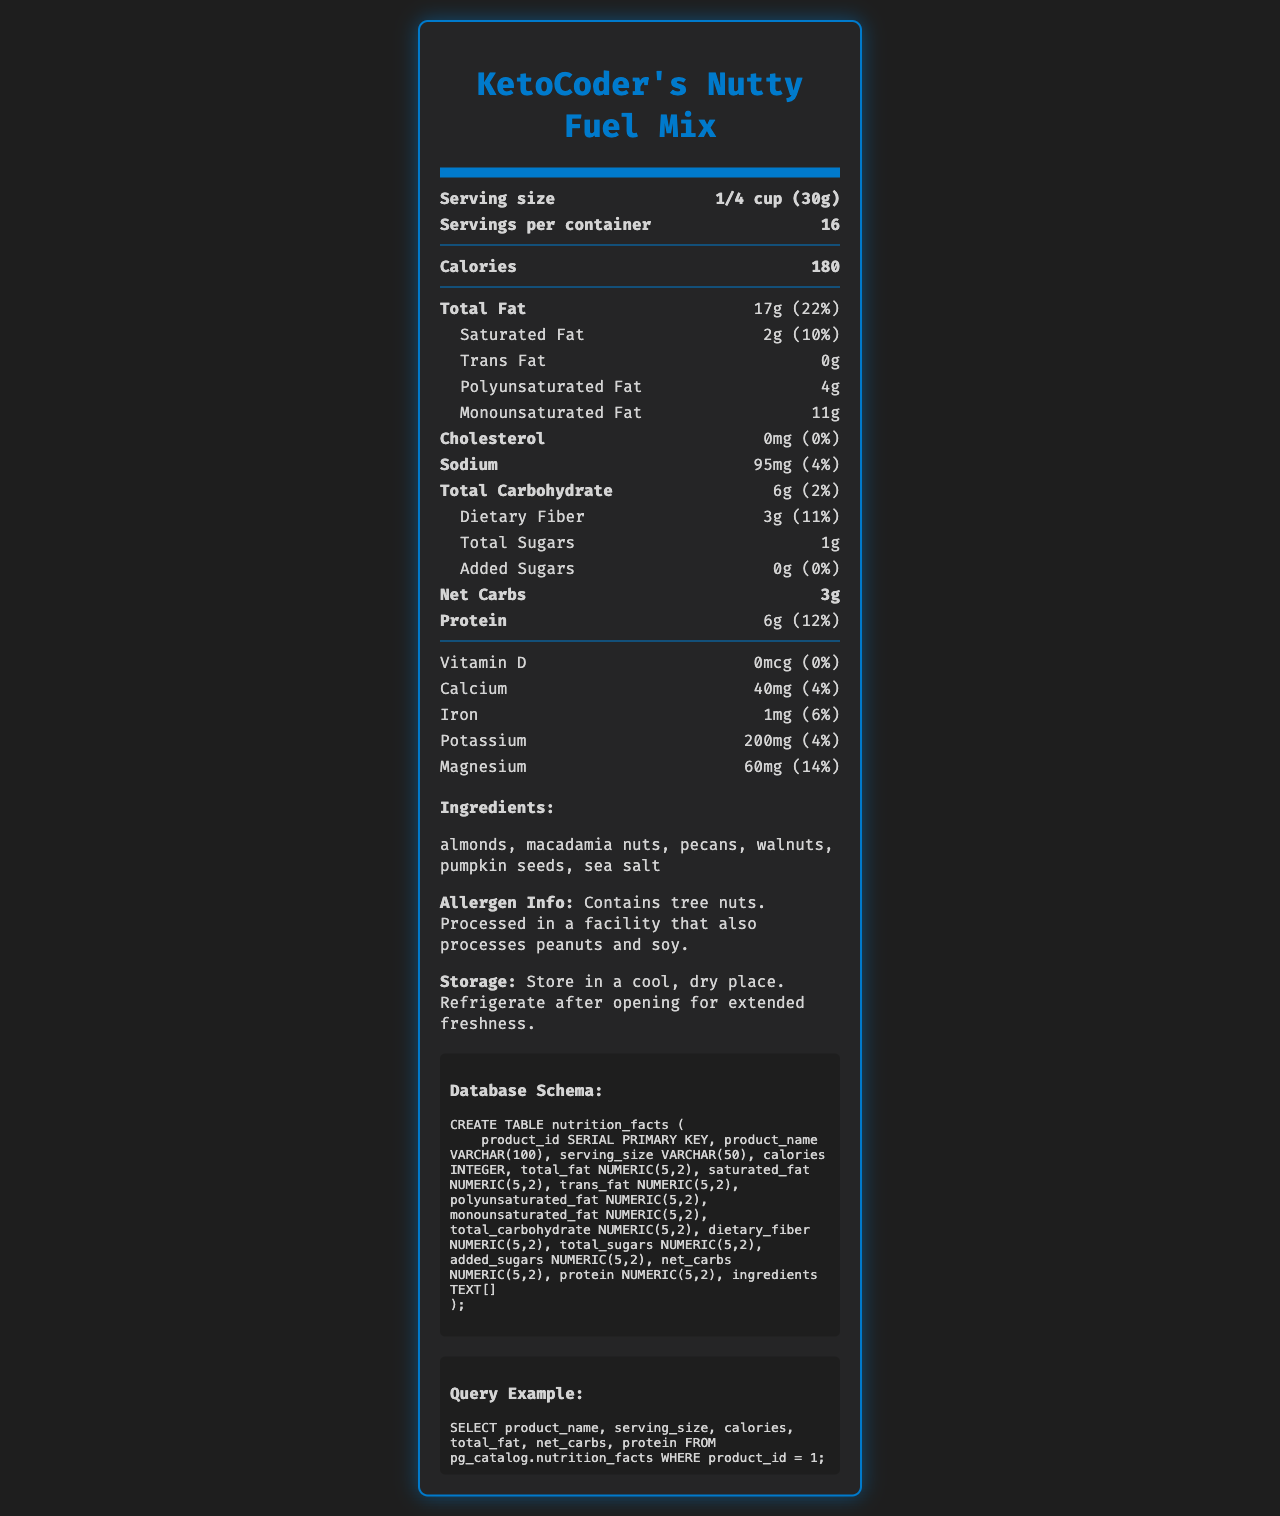how many calories are in one serving? The calories for one serving are listed directly in the nutrition label under the "Calories" section.
Answer: 180 what is the serving size? The serving size is stated at the top of the nutrition label next to "Serving size".
Answer: 1/4 cup (30g) how much saturated fat does one serving contain? The amount of saturated fat per serving is detailed under the "Total Fat" section with a breakdown indicating 2g of saturated fat.
Answer: 2g what is the daily value percentage of magnesium per serving? The daily value percentage of magnesium is listed under the "Vitamins and Minerals" section as 14%.
Answer: 14% how much protein is in each serving? The protein content per serving is listed in the nutrition label under "Protein".
Answer: 6g which of the following nuts is NOT an ingredient in KetoCoder's Nutty Fuel Mix? A. Almonds B. Cashews C. Walnuts D. Macadamia nuts The listed ingredients are almonds, macadamia nuts, pecans, walnuts, pumpkin seeds, and sea salt. Cashews are not mentioned.
Answer: B how much sodium does one serving contain? A. 95mg B. 0mg C. 200mg D. 40mg The sodium content per serving is given as 95mg, clearly mentioned under the "Sodium" section of the nutrition label.
Answer: A is there any added sugar in this product? The nutrition label specifies "Added Sugars" as 0g, which means there is no added sugar in the product.
Answer: No based on the nutrition facts, is this product high in fiber? The product contains 3g of dietary fiber per serving, which is 11% of the daily value, making it relatively high in fiber.
Answer: Yes summarize the content of this nutrition label. The summary captures the main aspects of the document including the nutritional breakdown, ingredients, and additional product information, offering a comprehensive view of the nut mix.
Answer: The document provides detailed nutrition information for KetoCoder's Nutty Fuel Mix, including serving size, calorie content, fat, cholesterol, sodium, carbohydrates, fiber, sugars, protein, and various vitamins and minerals. It also lists the ingredients, allergen information, storage instructions, and a sample database schema for storing this information. how much polyunsaturated fat is in the product? The nutrition label does not specify the amount of polyunsaturated fat; it only lists polyunsaturated fat without an amount.
Answer: Cannot be determined 